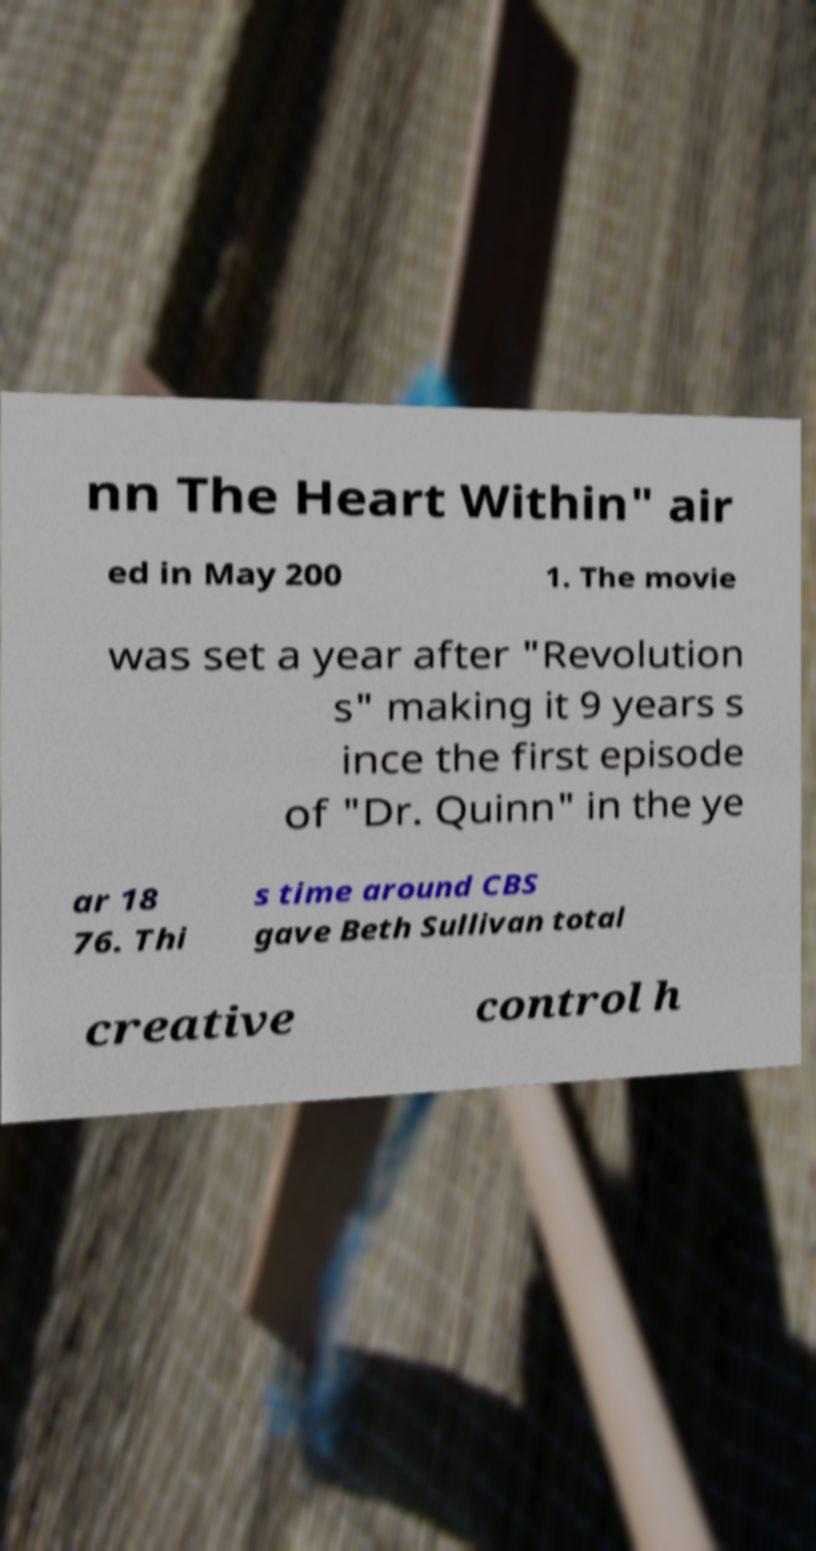Please read and relay the text visible in this image. What does it say? nn The Heart Within" air ed in May 200 1. The movie was set a year after "Revolution s" making it 9 years s ince the first episode of "Dr. Quinn" in the ye ar 18 76. Thi s time around CBS gave Beth Sullivan total creative control h 